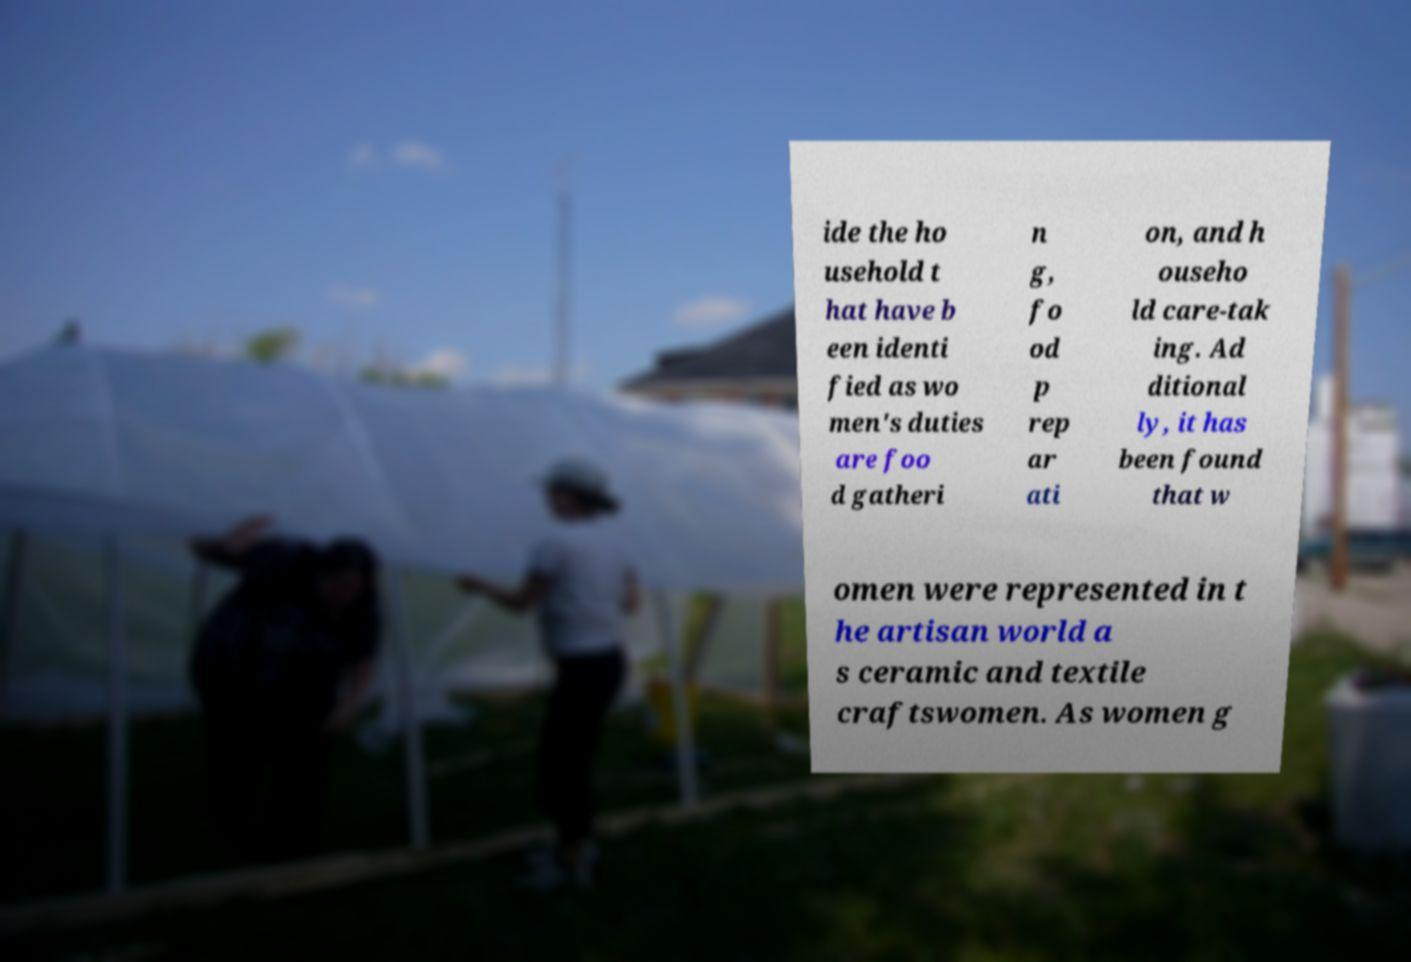Could you extract and type out the text from this image? ide the ho usehold t hat have b een identi fied as wo men's duties are foo d gatheri n g, fo od p rep ar ati on, and h ouseho ld care-tak ing. Ad ditional ly, it has been found that w omen were represented in t he artisan world a s ceramic and textile craftswomen. As women g 